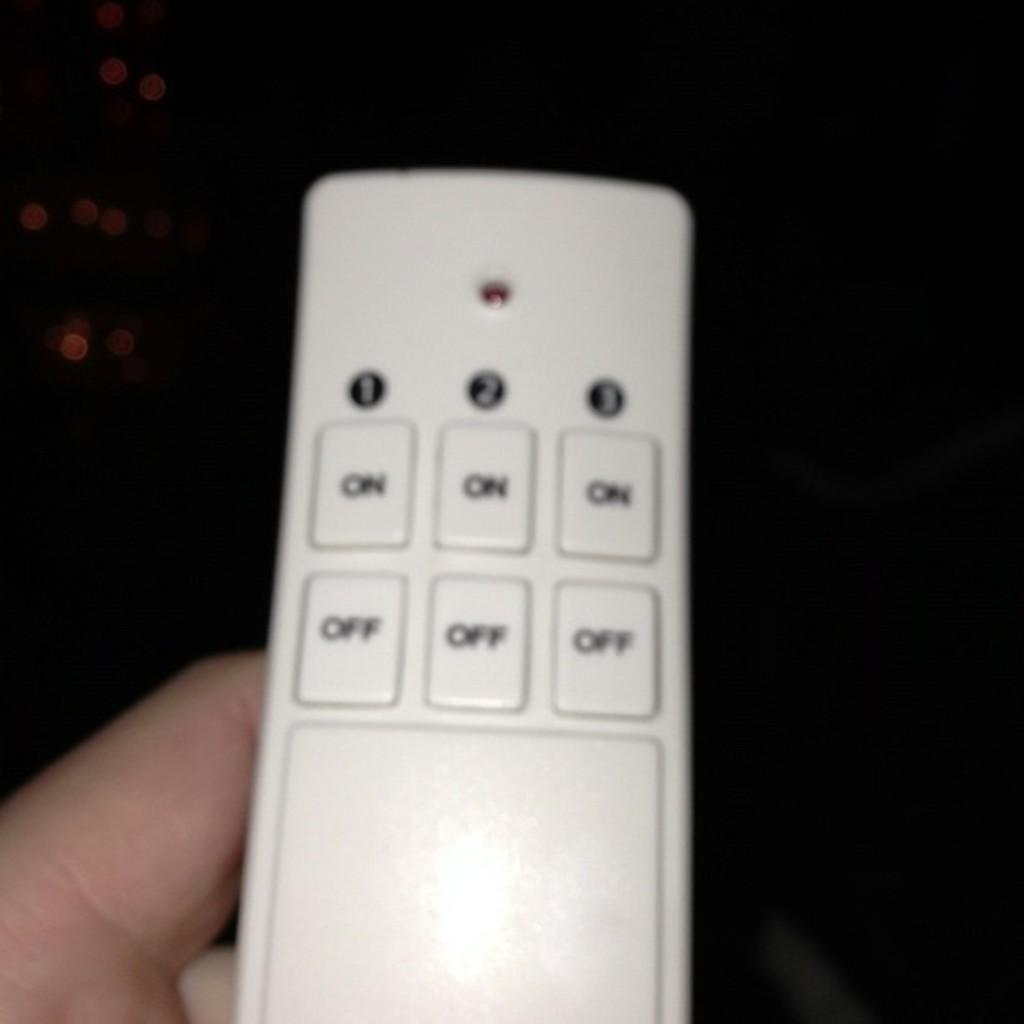Provide a one-sentence caption for the provided image. A white remote control has three ON buttons and three OFF buttons. 